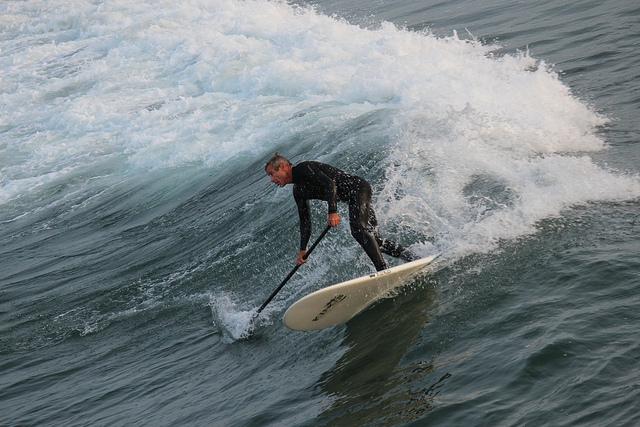What is the man holding in his hands?
Keep it brief. Paddle. Is the man wearing a bodysuit?
Write a very short answer. Yes. Does the person have a beard?
Quick response, please. No. Is this person riding on a wave?
Be succinct. Yes. 